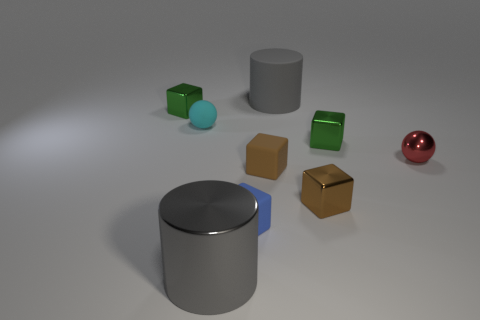Subtract all small brown matte cubes. How many cubes are left? 4 Add 1 large red things. How many objects exist? 10 Subtract all yellow balls. How many brown cubes are left? 2 Subtract all brown blocks. How many blocks are left? 3 Subtract 0 gray balls. How many objects are left? 9 Subtract all balls. How many objects are left? 7 Subtract 1 cubes. How many cubes are left? 4 Subtract all yellow balls. Subtract all cyan blocks. How many balls are left? 2 Subtract all tiny blue objects. Subtract all small shiny objects. How many objects are left? 4 Add 4 red spheres. How many red spheres are left? 5 